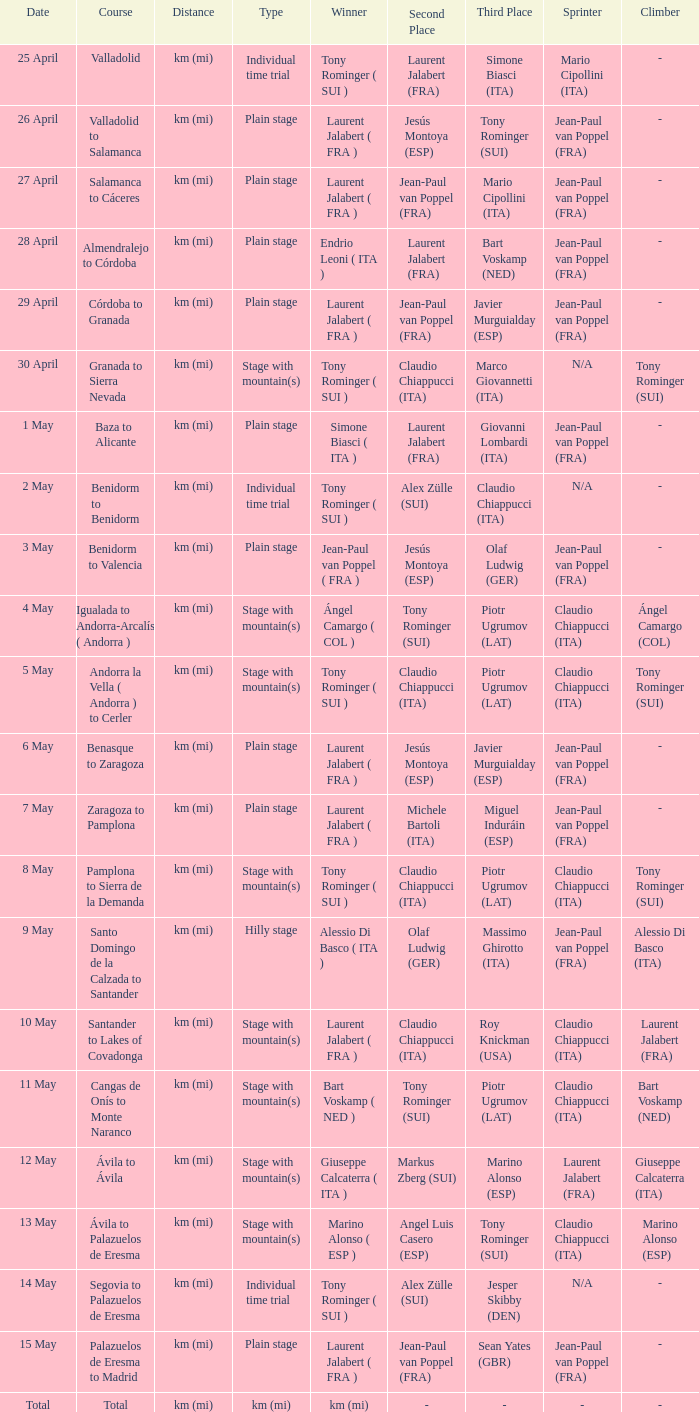What was the date with a winner of km (mi)? Total. 